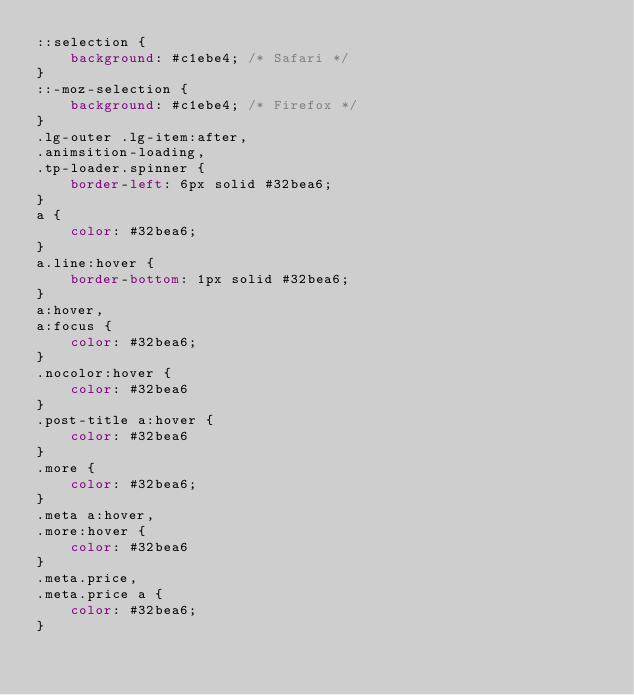<code> <loc_0><loc_0><loc_500><loc_500><_CSS_>::selection {
    background: #c1ebe4; /* Safari */
}
::-moz-selection {
    background: #c1ebe4; /* Firefox */
}
.lg-outer .lg-item:after,
.animsition-loading,
.tp-loader.spinner {
    border-left: 6px solid #32bea6;
}
a {
    color: #32bea6;
}
a.line:hover {
    border-bottom: 1px solid #32bea6;
}
a:hover,
a:focus {
    color: #32bea6;
}
.nocolor:hover {
    color: #32bea6
}
.post-title a:hover {
    color: #32bea6
}
.more {
    color: #32bea6;
}
.meta a:hover,
.more:hover {
    color: #32bea6
}
.meta.price,
.meta.price a {
    color: #32bea6;
}</code> 